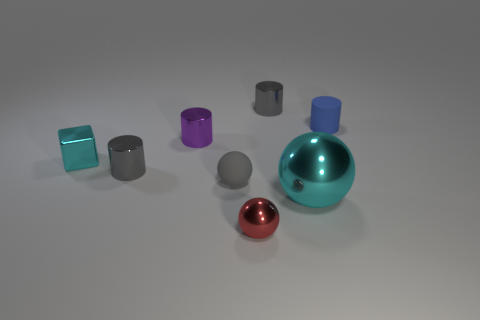What number of gray things are in front of the small gray metallic cylinder on the right side of the gray cylinder left of the tiny red ball?
Your answer should be very brief. 2. What color is the cylinder behind the blue rubber cylinder?
Give a very brief answer. Gray. The tiny gray thing that is to the right of the purple cylinder and in front of the tiny purple cylinder is made of what material?
Offer a terse response. Rubber. There is a thing that is to the right of the big cyan thing; how many tiny metal cylinders are left of it?
Your response must be concise. 3. The gray rubber object is what shape?
Ensure brevity in your answer.  Sphere. What is the shape of the tiny purple thing that is the same material as the red object?
Keep it short and to the point. Cylinder. Do the small rubber thing that is left of the small blue rubber cylinder and the tiny blue rubber object have the same shape?
Provide a short and direct response. No. What is the shape of the rubber object that is in front of the small matte cylinder?
Your response must be concise. Sphere. There is a object that is the same color as the big metal sphere; what shape is it?
Give a very brief answer. Cube. How many other blue objects are the same size as the blue thing?
Offer a very short reply. 0. 